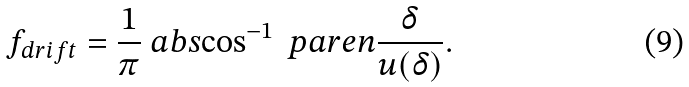<formula> <loc_0><loc_0><loc_500><loc_500>f _ { d r i f t } = \frac { 1 } { \pi } \ a b s { \cos ^ { - 1 } \ p a r e n { \frac { \delta } { u ( \delta ) } } } .</formula> 